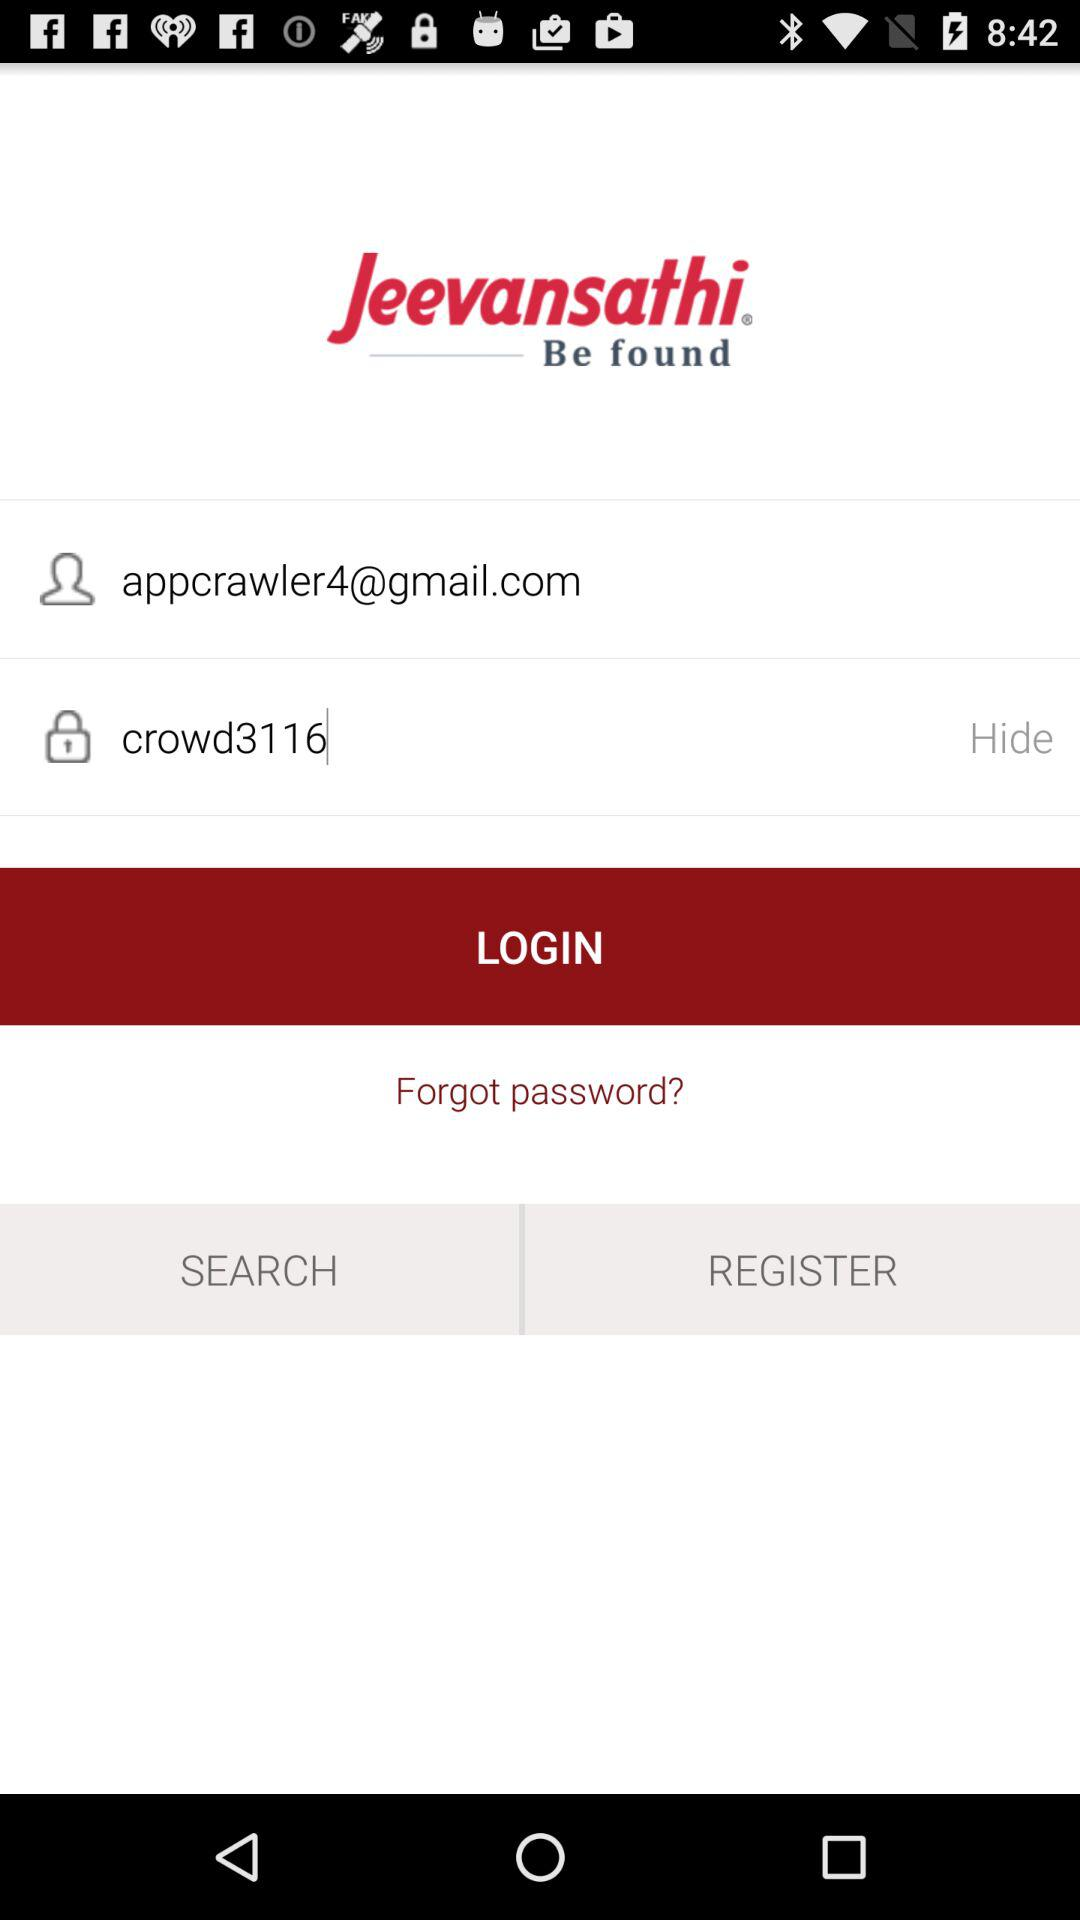What is the email address of the user? The email address of the user is appcrawler4@gmail.com. 